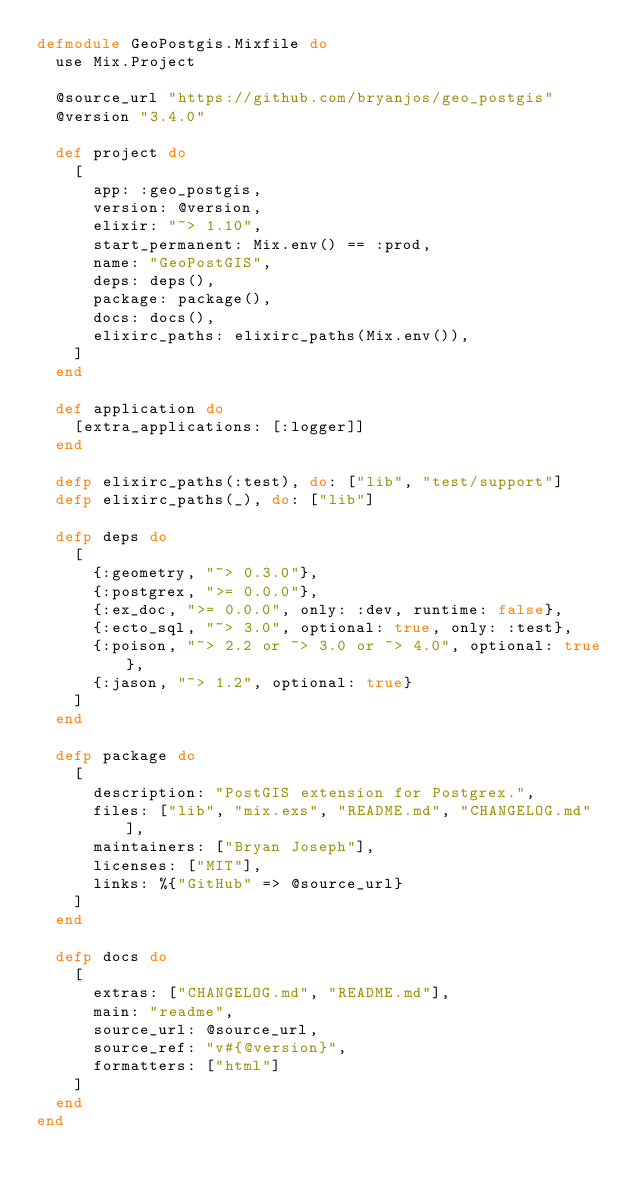<code> <loc_0><loc_0><loc_500><loc_500><_Elixir_>defmodule GeoPostgis.Mixfile do
  use Mix.Project

  @source_url "https://github.com/bryanjos/geo_postgis"
  @version "3.4.0"

  def project do
    [
      app: :geo_postgis,
      version: @version,
      elixir: "~> 1.10",
      start_permanent: Mix.env() == :prod,
      name: "GeoPostGIS",
      deps: deps(),
      package: package(),
      docs: docs(),
      elixirc_paths: elixirc_paths(Mix.env()),
    ]
  end

  def application do
    [extra_applications: [:logger]]
  end

  defp elixirc_paths(:test), do: ["lib", "test/support"]
  defp elixirc_paths(_), do: ["lib"]

  defp deps do
    [
      {:geometry, "~> 0.3.0"},
      {:postgrex, ">= 0.0.0"},
      {:ex_doc, ">= 0.0.0", only: :dev, runtime: false},
      {:ecto_sql, "~> 3.0", optional: true, only: :test},
      {:poison, "~> 2.2 or ~> 3.0 or ~> 4.0", optional: true},
      {:jason, "~> 1.2", optional: true}
    ]
  end

  defp package do
    [
      description: "PostGIS extension for Postgrex.",
      files: ["lib", "mix.exs", "README.md", "CHANGELOG.md"],
      maintainers: ["Bryan Joseph"],
      licenses: ["MIT"],
      links: %{"GitHub" => @source_url}
    ]
  end

  defp docs do
    [
      extras: ["CHANGELOG.md", "README.md"],
      main: "readme",
      source_url: @source_url,
      source_ref: "v#{@version}",
      formatters: ["html"]
    ]
  end
end
</code> 